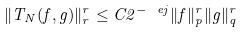Convert formula to latex. <formula><loc_0><loc_0><loc_500><loc_500>\| T _ { N } ( f , g ) \| _ { r } ^ { r } \leq C 2 ^ { - \ e j } \| f \| _ { p } ^ { r } \| g \| _ { q } ^ { r } \,</formula> 